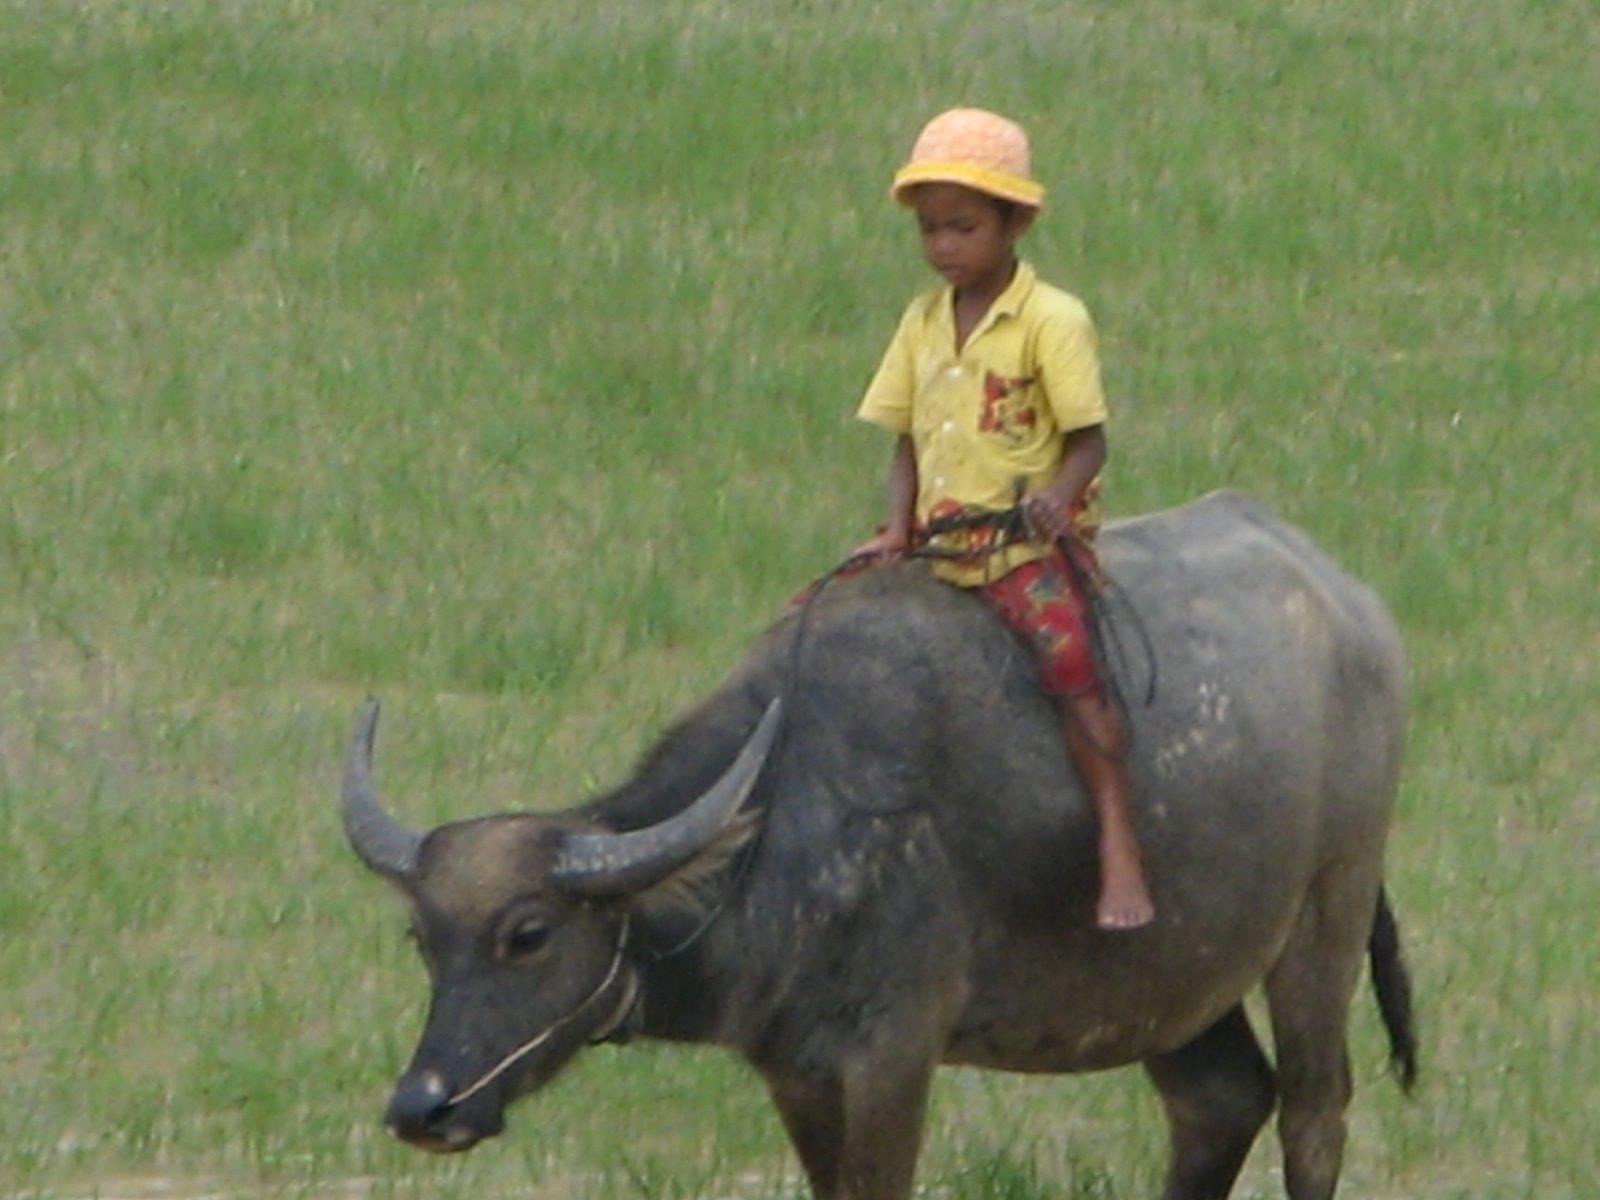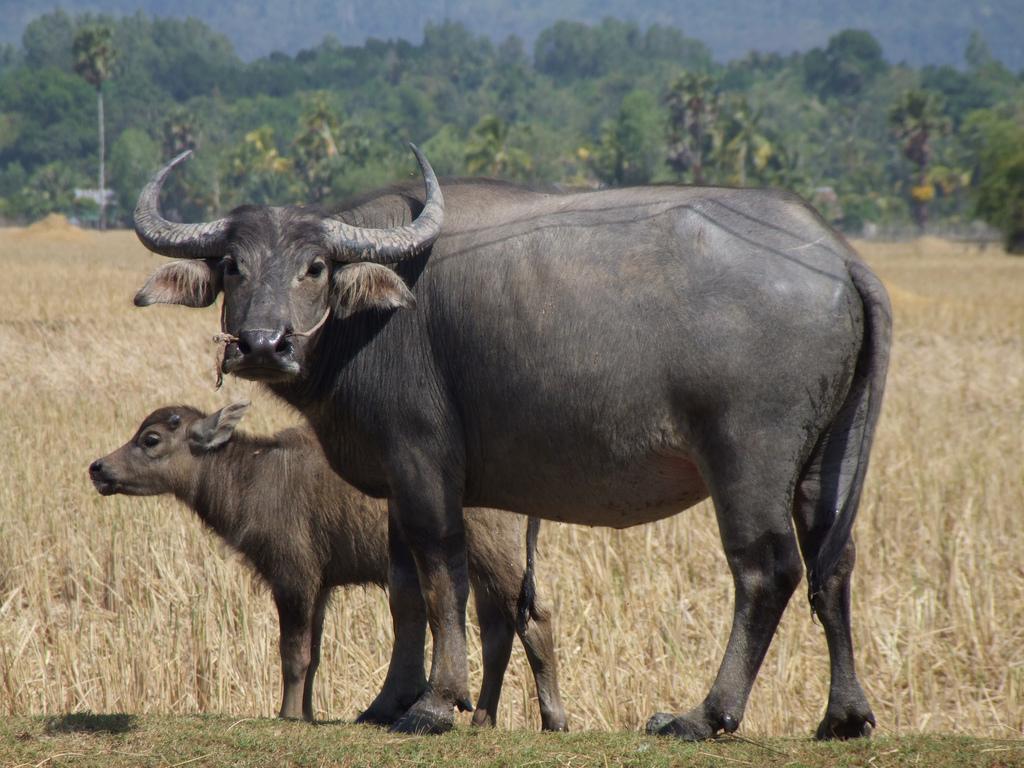The first image is the image on the left, the second image is the image on the right. Given the left and right images, does the statement "A young person wearing head covering is sitting astride a horned animal." hold true? Answer yes or no. Yes. The first image is the image on the left, the second image is the image on the right. Examine the images to the left and right. Is the description "One of the pictures shows a boy riding a water buffalo, and the other shows two water buffalo together." accurate? Answer yes or no. Yes. 